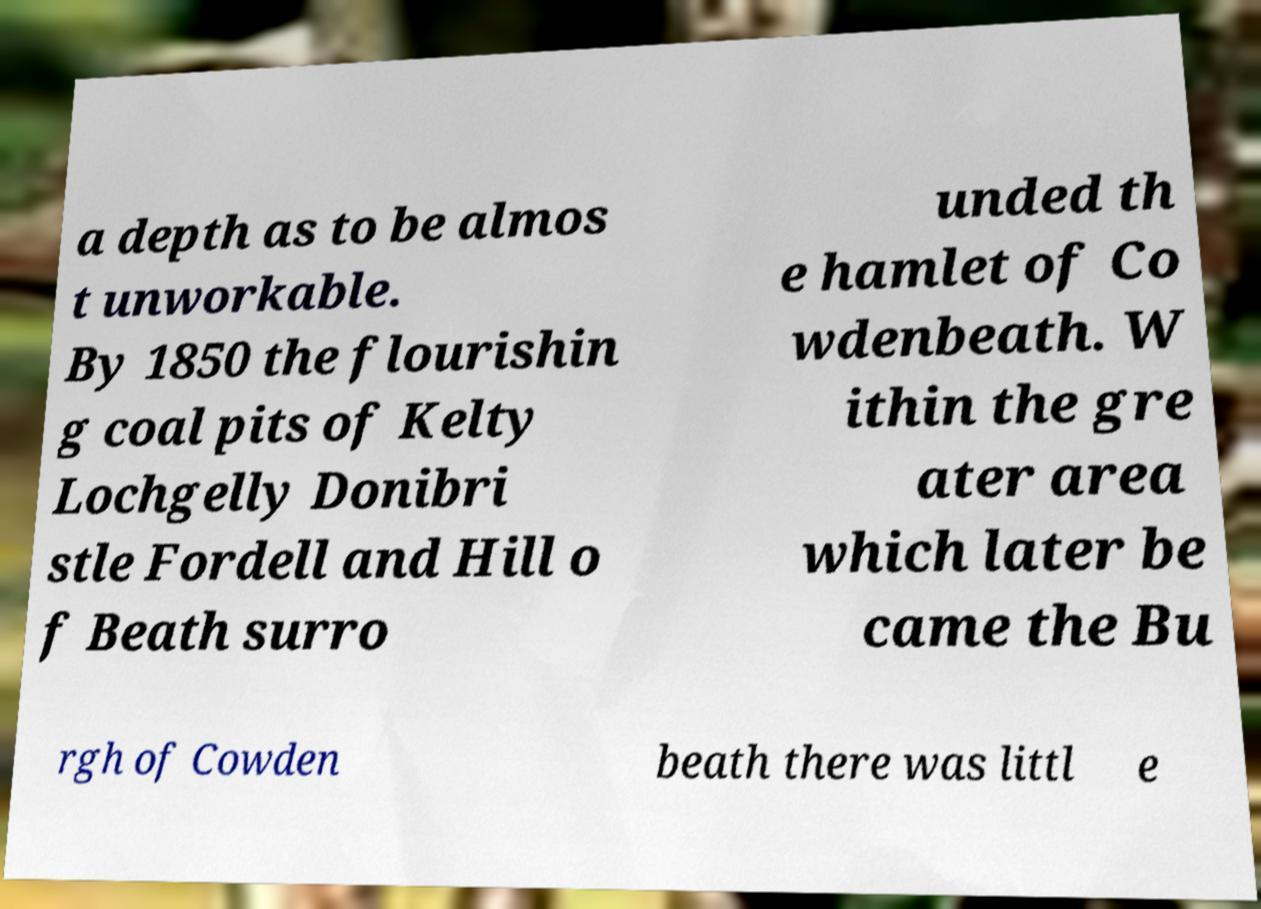Please read and relay the text visible in this image. What does it say? a depth as to be almos t unworkable. By 1850 the flourishin g coal pits of Kelty Lochgelly Donibri stle Fordell and Hill o f Beath surro unded th e hamlet of Co wdenbeath. W ithin the gre ater area which later be came the Bu rgh of Cowden beath there was littl e 